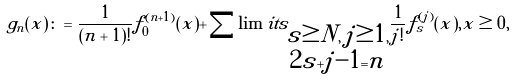Convert formula to latex. <formula><loc_0><loc_0><loc_500><loc_500>g _ { n } ( x ) \colon = \frac { 1 } { ( n + 1 ) ! } f _ { 0 } ^ { ( n + 1 ) } ( x ) + \sum \lim i t s _ { \substack { s \geq N , \, j \geq 1 , \\ 2 s + j - 1 = n } } \frac { 1 } { j ! } f _ { s } ^ { ( j ) } ( x ) , x \geq 0 ,</formula> 